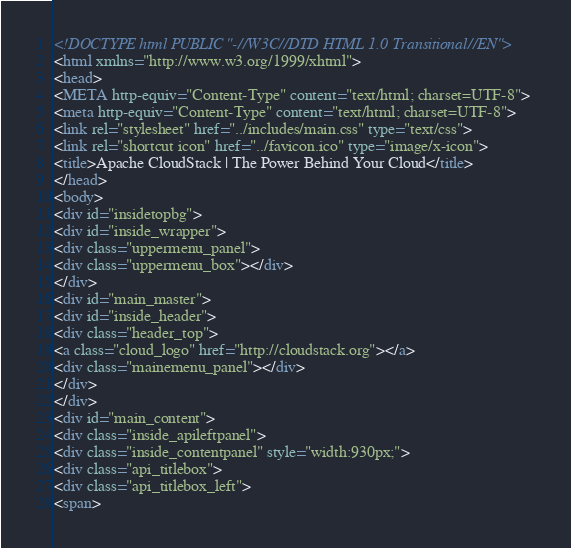Convert code to text. <code><loc_0><loc_0><loc_500><loc_500><_HTML_><!DOCTYPE html PUBLIC "-//W3C//DTD HTML 1.0 Transitional//EN">
<html xmlns="http://www.w3.org/1999/xhtml">
<head>
<META http-equiv="Content-Type" content="text/html; charset=UTF-8">
<meta http-equiv="Content-Type" content="text/html; charset=UTF-8">
<link rel="stylesheet" href="../includes/main.css" type="text/css">
<link rel="shortcut icon" href="../favicon.ico" type="image/x-icon">
<title>Apache CloudStack | The Power Behind Your Cloud</title>
</head>
<body>
<div id="insidetopbg">
<div id="inside_wrapper">
<div class="uppermenu_panel">
<div class="uppermenu_box"></div>
</div>
<div id="main_master">
<div id="inside_header">
<div class="header_top">
<a class="cloud_logo" href="http://cloudstack.org"></a>
<div class="mainemenu_panel"></div>
</div>
</div>
<div id="main_content">
<div class="inside_apileftpanel">
<div class="inside_contentpanel" style="width:930px;">
<div class="api_titlebox">
<div class="api_titlebox_left">
<span></code> 